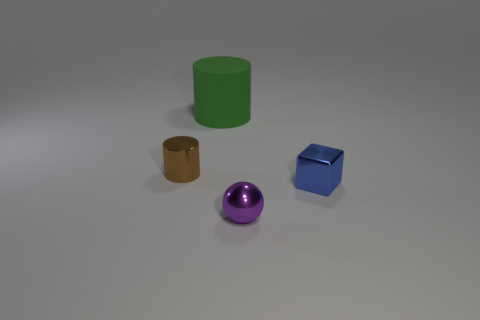Are any big green rubber cylinders visible?
Your answer should be very brief. Yes. There is a object that is behind the small object on the left side of the matte cylinder; what shape is it?
Ensure brevity in your answer.  Cylinder. How many things are either small green blocks or things behind the brown shiny cylinder?
Your answer should be compact. 1. There is a object behind the small object that is left of the tiny thing that is in front of the blue shiny cube; what is its color?
Make the answer very short. Green. There is another thing that is the same shape as the large object; what is it made of?
Make the answer very short. Metal. What is the color of the big rubber cylinder?
Give a very brief answer. Green. How many rubber things are either large cyan cubes or tiny things?
Your answer should be compact. 0. There is a cylinder that is behind the metallic object that is behind the small blue thing; are there any small objects that are to the right of it?
Make the answer very short. Yes. Are there any green objects left of the small blue metallic object?
Your response must be concise. Yes. Is there a thing that is behind the thing to the left of the big green rubber thing?
Your answer should be very brief. Yes. 